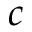<formula> <loc_0><loc_0><loc_500><loc_500>c</formula> 